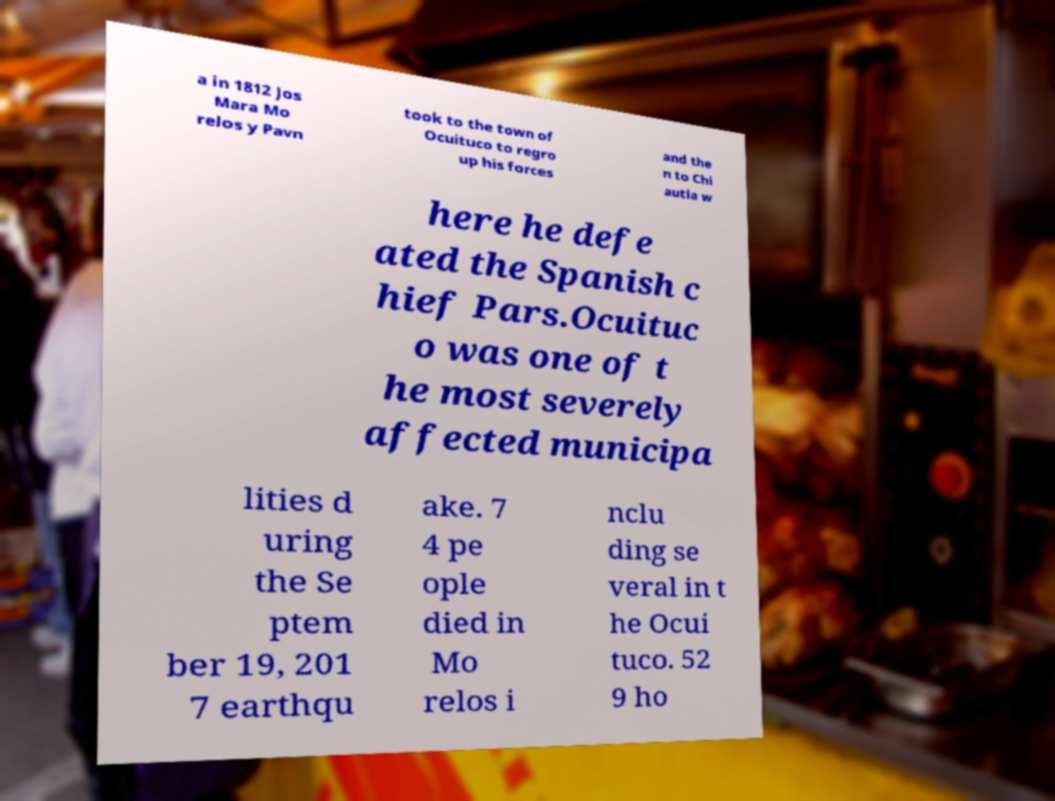Please read and relay the text visible in this image. What does it say? a in 1812 Jos Mara Mo relos y Pavn took to the town of Ocuituco to regro up his forces and the n to Chi autla w here he defe ated the Spanish c hief Pars.Ocuituc o was one of t he most severely affected municipa lities d uring the Se ptem ber 19, 201 7 earthqu ake. 7 4 pe ople died in Mo relos i nclu ding se veral in t he Ocui tuco. 52 9 ho 